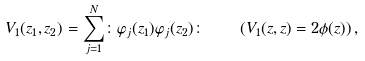<formula> <loc_0><loc_0><loc_500><loc_500>V _ { 1 } ( z _ { 1 } , z _ { 2 } ) = \sum _ { j = 1 } ^ { N } \colon \varphi _ { j } ( z _ { 1 } ) \varphi _ { j } ( z _ { 2 } ) \colon \quad ( V _ { 1 } ( z , z ) = 2 \phi ( z ) ) \, ,</formula> 